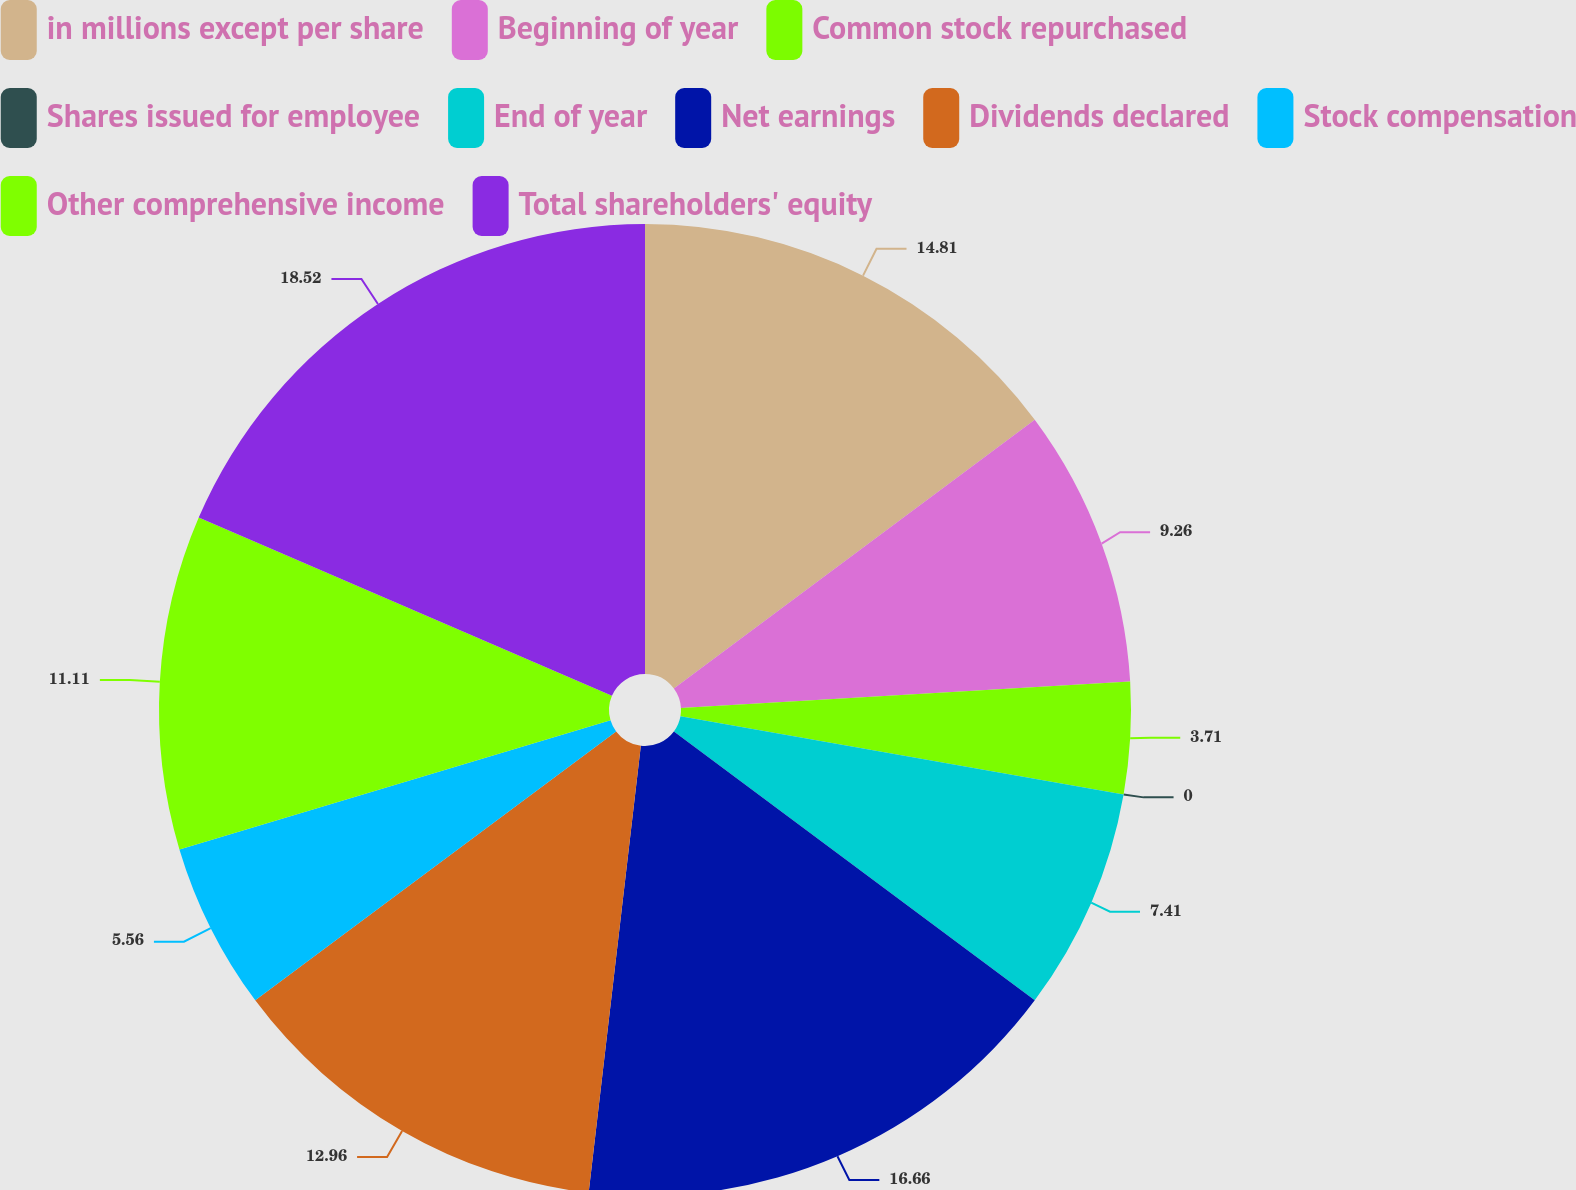Convert chart to OTSL. <chart><loc_0><loc_0><loc_500><loc_500><pie_chart><fcel>in millions except per share<fcel>Beginning of year<fcel>Common stock repurchased<fcel>Shares issued for employee<fcel>End of year<fcel>Net earnings<fcel>Dividends declared<fcel>Stock compensation<fcel>Other comprehensive income<fcel>Total shareholders' equity<nl><fcel>14.81%<fcel>9.26%<fcel>3.71%<fcel>0.0%<fcel>7.41%<fcel>16.66%<fcel>12.96%<fcel>5.56%<fcel>11.11%<fcel>18.52%<nl></chart> 